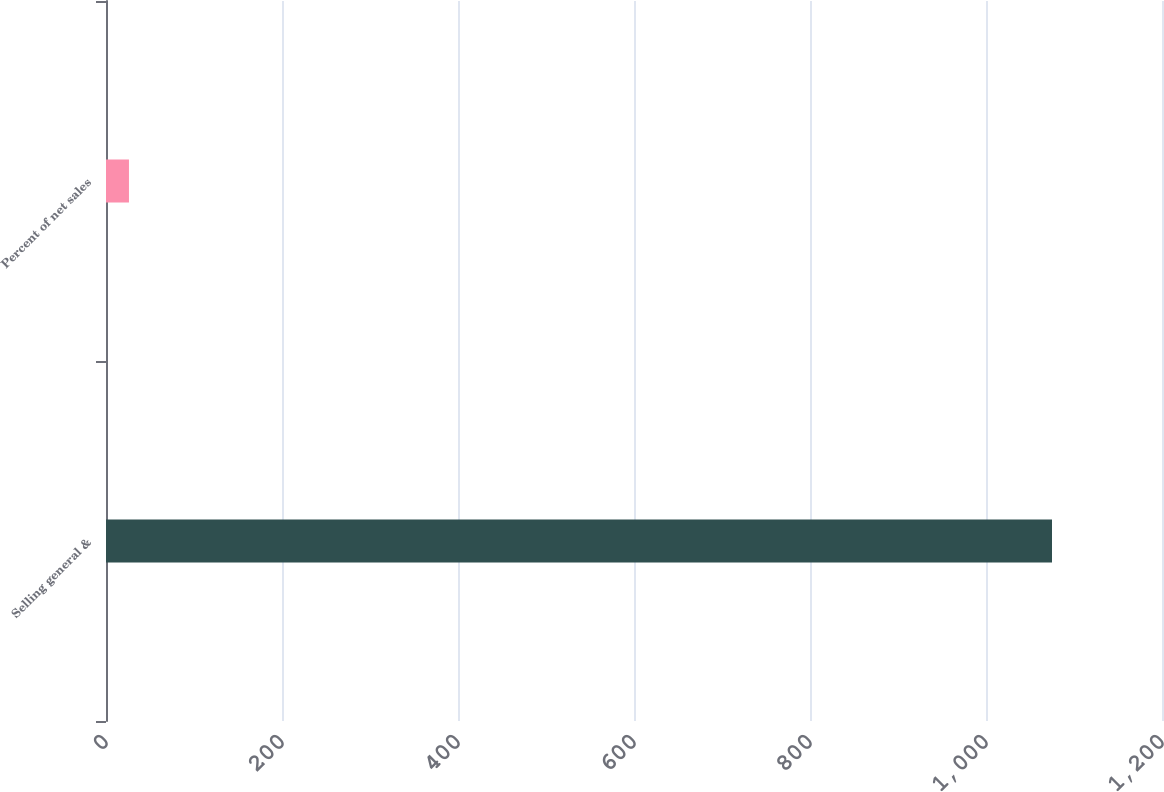Convert chart to OTSL. <chart><loc_0><loc_0><loc_500><loc_500><bar_chart><fcel>Selling general &<fcel>Percent of net sales<nl><fcel>1075<fcel>26.1<nl></chart> 